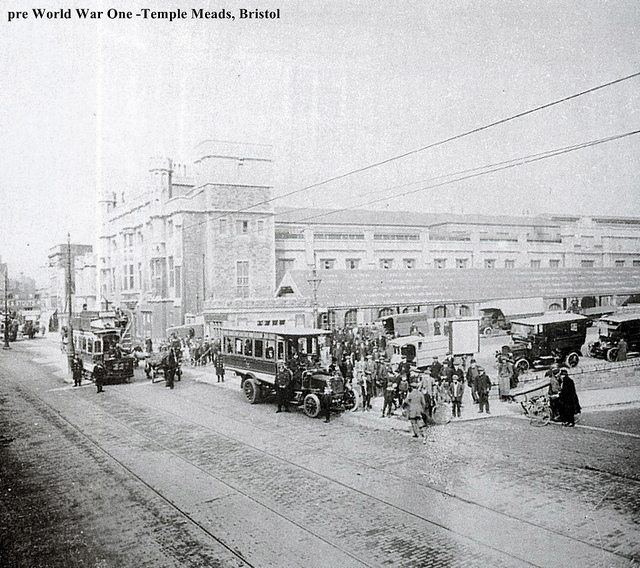Please transcribe the text in this image. Bristol pre World War Meads, -Temple One 